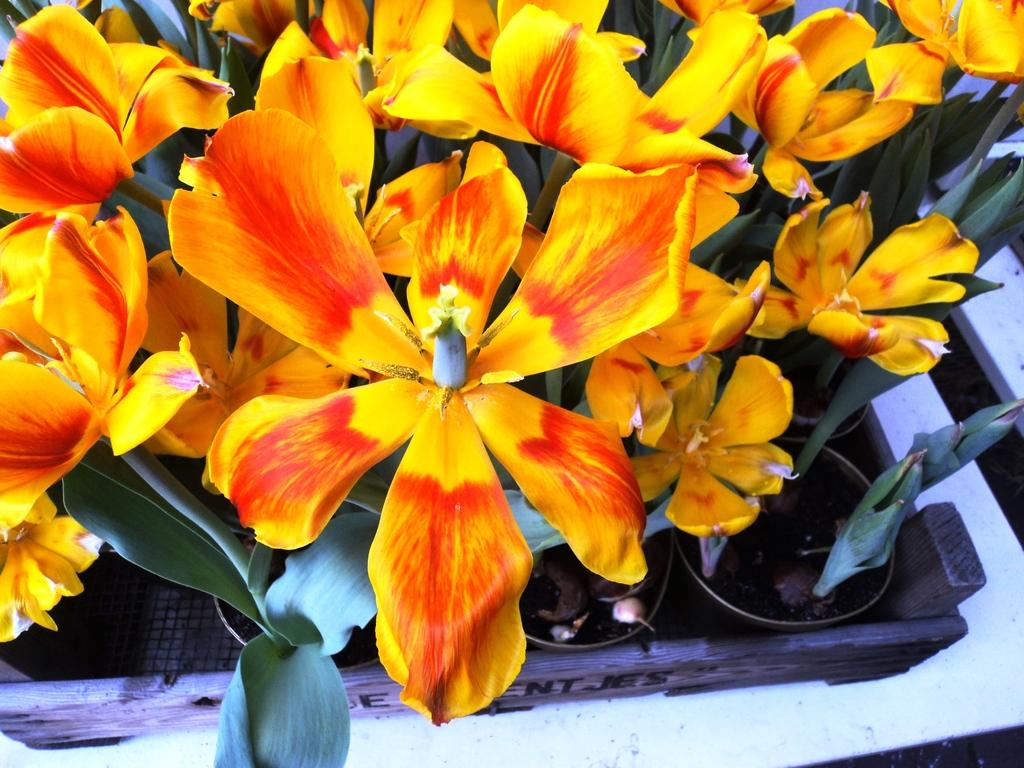What type of view is shown in the image? The image is a top view. What can be seen in the image besides the view? There are potted plants with flowers in the image. How are the potted plants arranged or held in the image? There is a wooden basket holding the potted plants. What type of chain can be seen connecting the potted plants in the image? There is no chain present in the image; the potted plants are held in a wooden basket. Can you spot a toad sitting on one of the potted plants in the image? There is no toad present in the image; it only features potted plants with flowers and a wooden basket. 